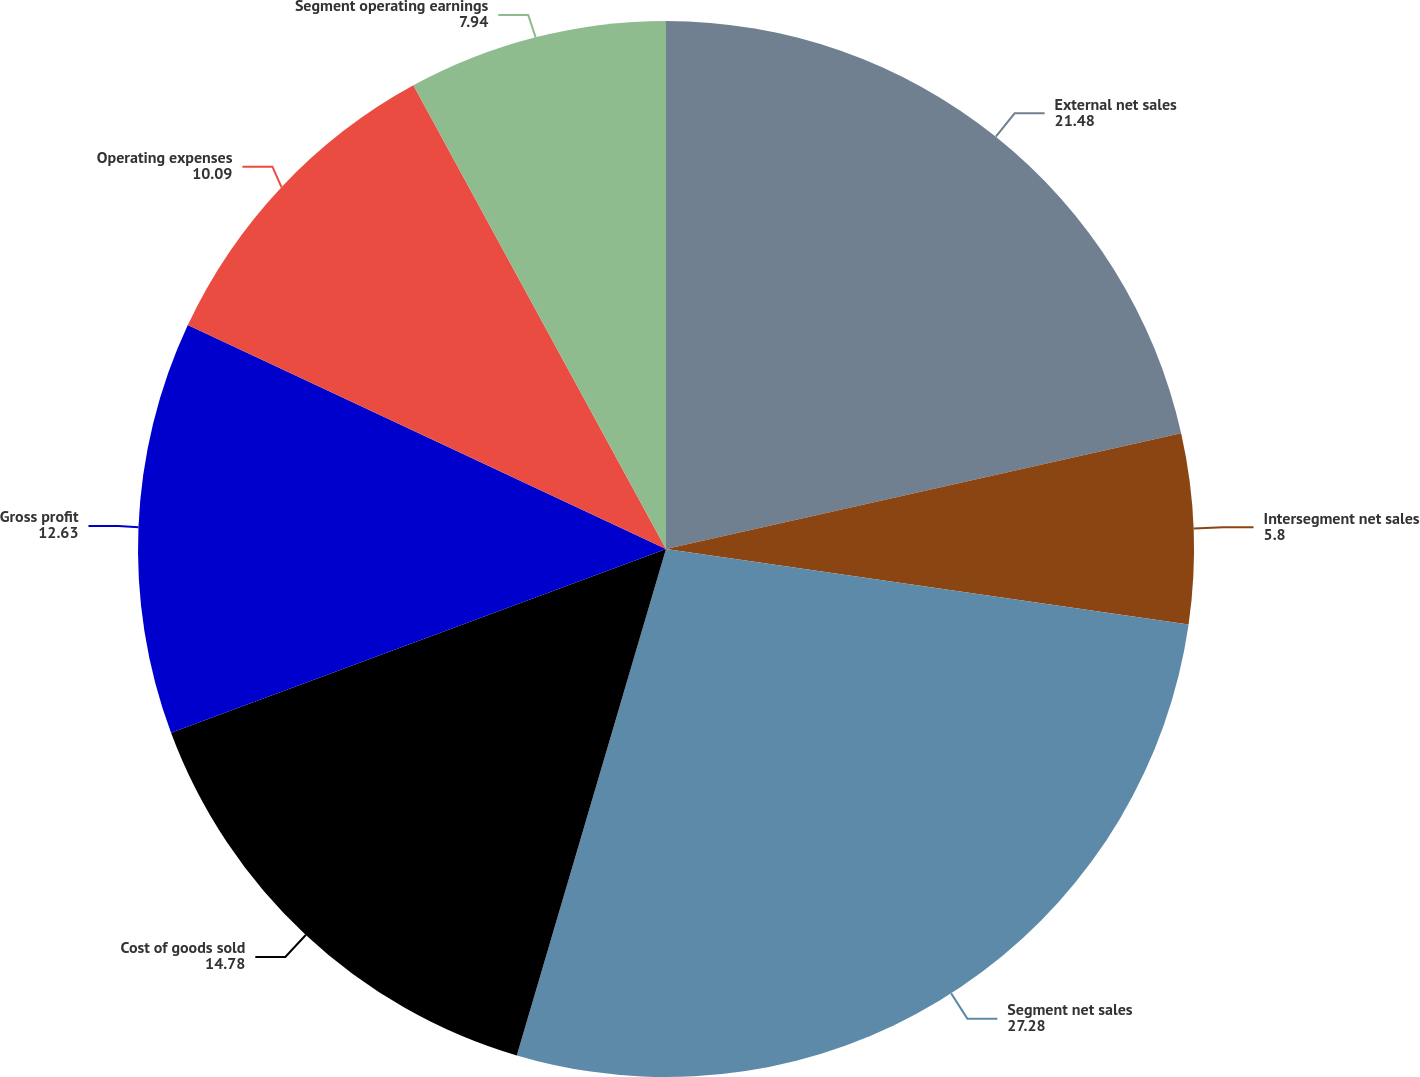<chart> <loc_0><loc_0><loc_500><loc_500><pie_chart><fcel>External net sales<fcel>Intersegment net sales<fcel>Segment net sales<fcel>Cost of goods sold<fcel>Gross profit<fcel>Operating expenses<fcel>Segment operating earnings<nl><fcel>21.48%<fcel>5.8%<fcel>27.28%<fcel>14.78%<fcel>12.63%<fcel>10.09%<fcel>7.94%<nl></chart> 